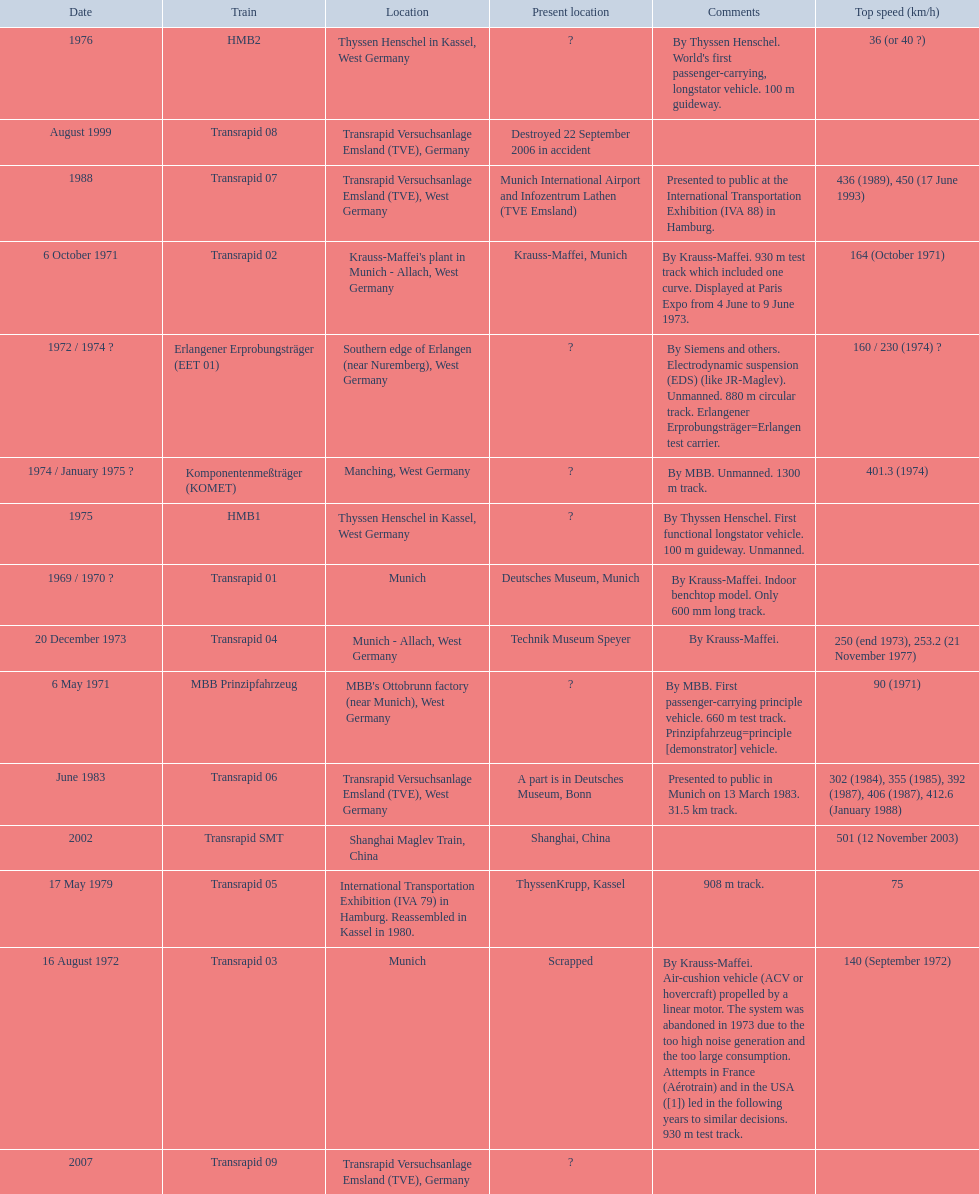What is the top speed reached by any trains shown here? 501 (12 November 2003). What train has reached a top speed of 501? Transrapid SMT. 